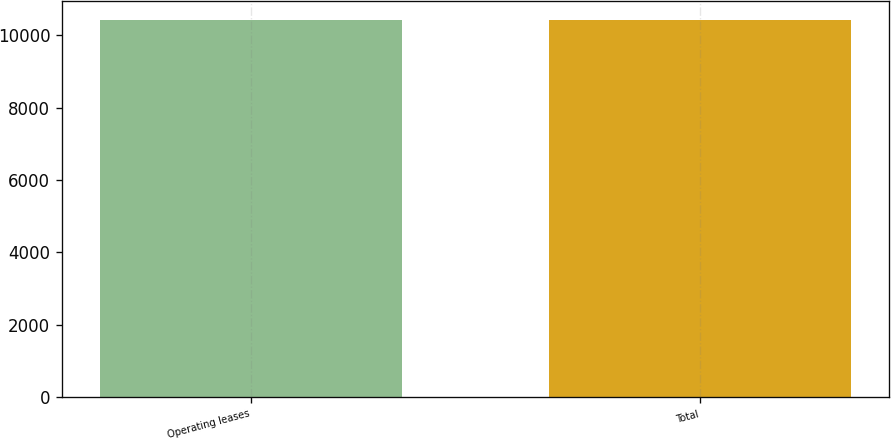Convert chart to OTSL. <chart><loc_0><loc_0><loc_500><loc_500><bar_chart><fcel>Operating leases<fcel>Total<nl><fcel>10410<fcel>10410.1<nl></chart> 